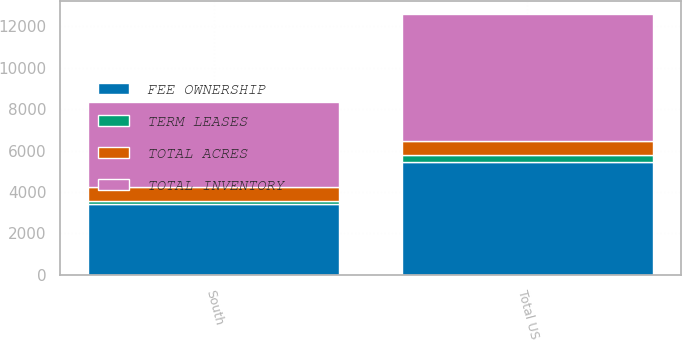Convert chart. <chart><loc_0><loc_0><loc_500><loc_500><stacked_bar_chart><ecel><fcel>South<fcel>Total US<nl><fcel>TERM LEASES<fcel>138<fcel>295<nl><fcel>FEE OWNERSHIP<fcel>3434<fcel>5472<nl><fcel>TOTAL ACRES<fcel>681<fcel>681<nl><fcel>TOTAL INVENTORY<fcel>4115<fcel>6153<nl></chart> 